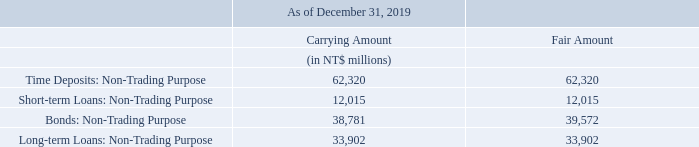QUANTITATIVE AND QUALITATIVE DISCLOSURES ABOUT MARKET RISK
Market risk is the risk of loss related to adverse changes in market prices, including interest rates and foreign exchange rates, of financial instruments. We are exposed to various types of market risks, including changes in interest rates and foreign currency exchange rates, in the normal course of business.
We use financial instruments, including variable rate debt and swaps and foreign exchange spot transactions, to manage risks associated with our interest rate and foreign currency exposures through a controlled program of risk management in accordance with established policies. These policies are reviewed and approved by our board of directors and stockholders’ meeting. Our treasury operations are subject to internal audit on a regular basis. We do not hold or issue derivative financial instruments for speculatively purposes.
Since export sales are primarily conducted in U.S. dollars, we had U.S. dollar-denominated accounts receivable of US$626 million as of December 31, 2019. As of the same date, we also had Japanese Yen-denominated accounts receivable of ¥14,266 million attributable to our Japanese operations and Renminbi-denominated accounts receivable of RMB¥710 million attributable to our China operations. We had U.S. dollar-, Japanese Yen- and Renminbi-denominated accounts payables of US$128 million, ¥7,193 million and RMB¥262 million, respectively, as of December 31, 2019.
Our primary market risk exposures relate to interest rate movements on borrowings and exchange rate movements on foreign currency denominated accounts receivable, capital expenditures relating to equipment used in manufacturing processes (including lithography, etching and chemical vapor deposition) and purchased primarily from Europe, Japan and the United States.
The following table provides information as of December 31, 2019 on our market risk sensitive financial instruments.
What is market risk? Market risk is the risk of loss related to adverse changes in market prices, including interest rates and foreign exchange rates, of financial instruments. What were the Time Deposits: Non-Trading Purpose carrying amount?
Answer scale should be: million. 62,320. What were the accounts receivables in 2019? Us$626 million. What is the difference in Time Deposits: Non-Trading Purpose between Carrying Amount and Fair Amount?
Answer scale should be: million. 62,320 - 62,320
Answer: 0. What is the difference between Bonds: Non-Trading Purpose Carrying Amount and Fair Amount?
Answer scale should be: million. 38,781 - 39,572
Answer: -791. What is the percentage increase / (decrease) of the Long-term Loans: Non-Trading Purpose Carrying Amount versus the Fair Amount?
Answer scale should be: percent. 33,902 / 33,902 - 1
Answer: 0. 